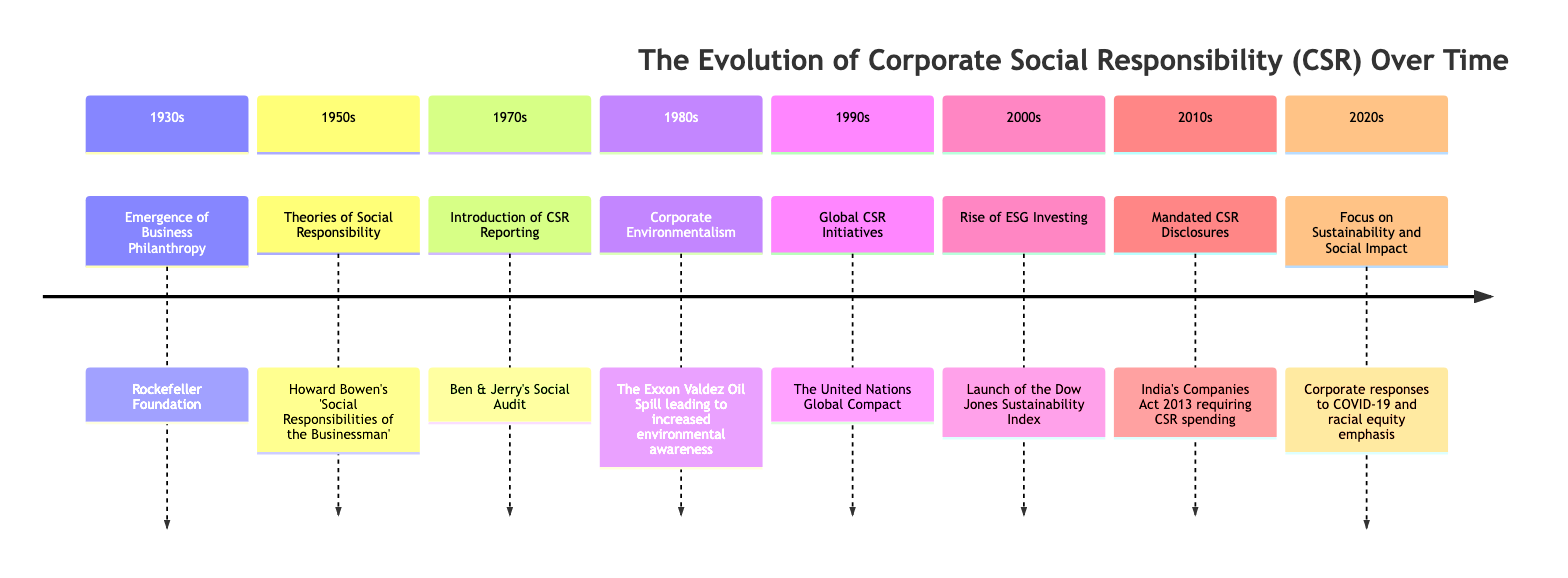What major milestone occurred in the 1950s? The diagram indicates that the major milestone in the 1950s was "Theories of Social Responsibility" associated with Howard Bowen's work.
Answer: Theories of Social Responsibility What year did the United Nations Global Compact launch? According to the timeline in the diagram, the United Nations Global Compact was launched in the 1990s, specifically highlighted as a major CSR initiative.
Answer: 1990s How many sections are there in the timeline? The diagram displays a total of 8 sections, representing different decades with key milestones in CSR development.
Answer: 8 Which major environmental event influenced corporate environmentalism in the 1980s? The timeline states that the Exxon Valdez Oil Spill significantly influenced increased environmental awareness, marking a major event in the 1980s.
Answer: Exxon Valdez Oil Spill What prompted the focus on sustainability in the 2020s? The diagram reveals that the focus on sustainability and social impact in the 2020s largely stemmed from corporate responses to COVID-19 and an emphasis on racial equity.
Answer: COVID-19 and racial equity What did the Companies Act 2013 entail in relation to CSR? The timeline indicates that India’s Companies Act 2013 mandated CSR disclosures, requiring companies to disclose their CSR spending.
Answer: Mandated CSR Disclosures What was the first instance of CSR reporting mentioned? The diagram notes that the first instance of CSR reporting highlighted in the timeline was Ben & Jerry's Social Audit in the 1970s.
Answer: Ben & Jerry's Social Audit Which decade saw the launch of the Dow Jones Sustainability Index? The diagram illustrates that the Dow Jones Sustainability Index was launched in the 2000s, marking a significant development in ESG investing.
Answer: 2000s 